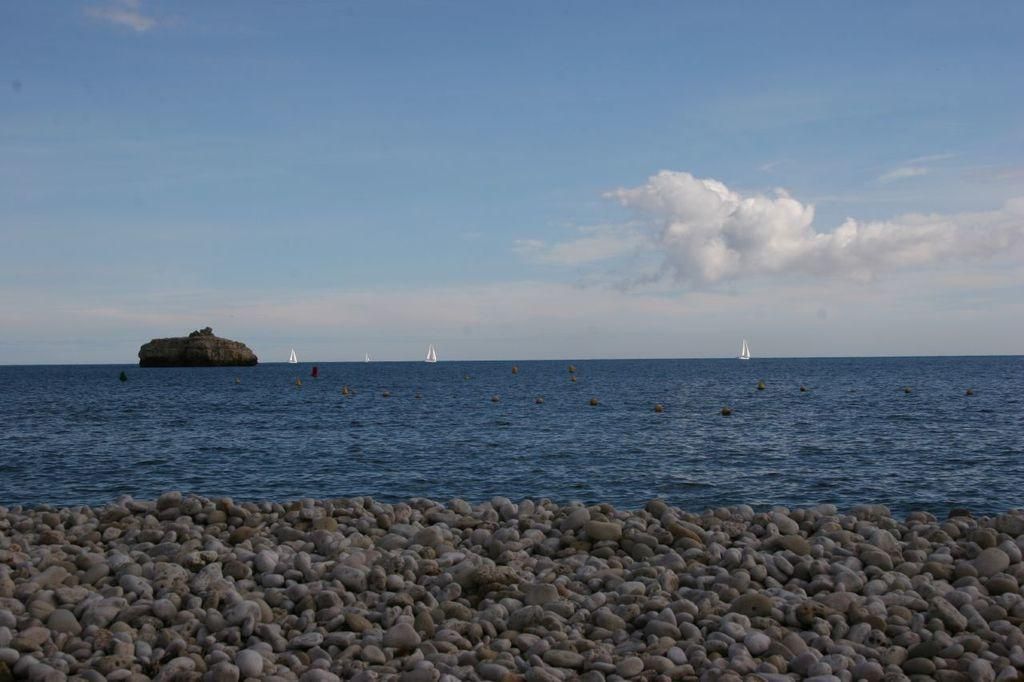What is the primary element in the image? There is water in the image. What can be seen floating on the water? There are boats in the image. What type of objects are present in the water? There are stones in the image. What is visible above the water? The sky is visible in the image. What can be observed in the sky? Clouds are present in the sky. What type of record is the queen holding in the image? There is no record or queen present in the image. What color is the dress worn by the queen in the image? There is no queen or dress present in the image. 